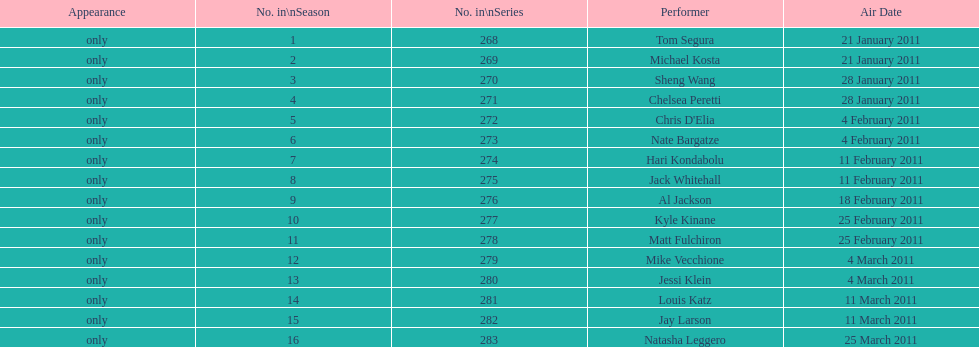How many episodes only had one performer? 16. 